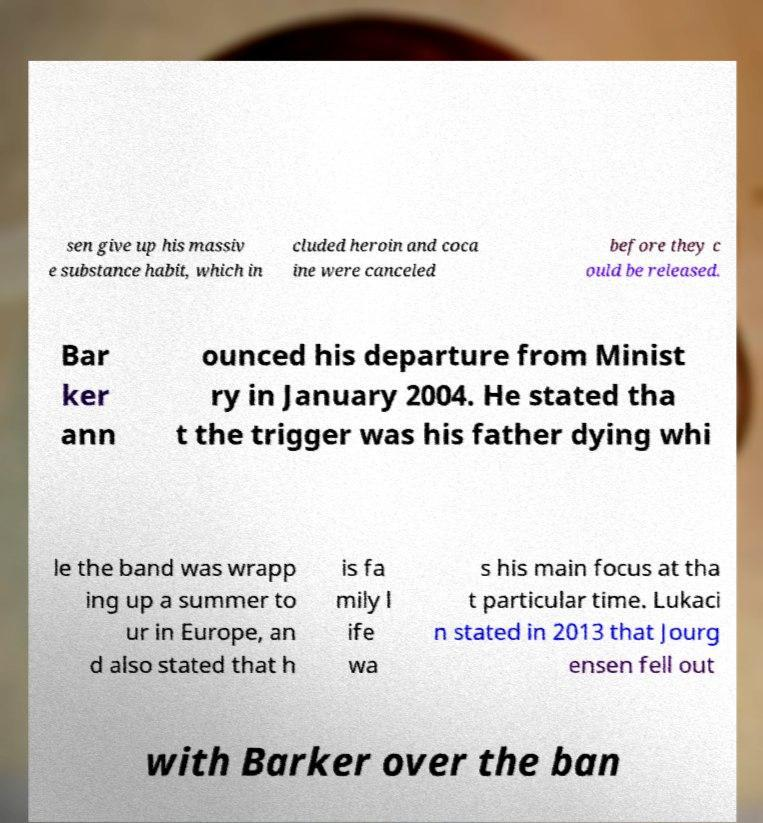I need the written content from this picture converted into text. Can you do that? sen give up his massiv e substance habit, which in cluded heroin and coca ine were canceled before they c ould be released. Bar ker ann ounced his departure from Minist ry in January 2004. He stated tha t the trigger was his father dying whi le the band was wrapp ing up a summer to ur in Europe, an d also stated that h is fa mily l ife wa s his main focus at tha t particular time. Lukaci n stated in 2013 that Jourg ensen fell out with Barker over the ban 